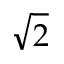Convert formula to latex. <formula><loc_0><loc_0><loc_500><loc_500>\sqrt { 2 }</formula> 